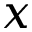Convert formula to latex. <formula><loc_0><loc_0><loc_500><loc_500>x</formula> 